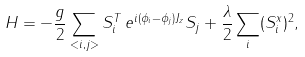Convert formula to latex. <formula><loc_0><loc_0><loc_500><loc_500>H = - \frac { g } 2 \sum _ { < i , j > } S ^ { T } _ { i } \, e ^ { i ( \phi _ { i } - \phi _ { j } ) J _ { z } } S _ { j } + \frac { \lambda } 2 \sum _ { i } ( S ^ { x } _ { i } ) ^ { 2 } ,</formula> 